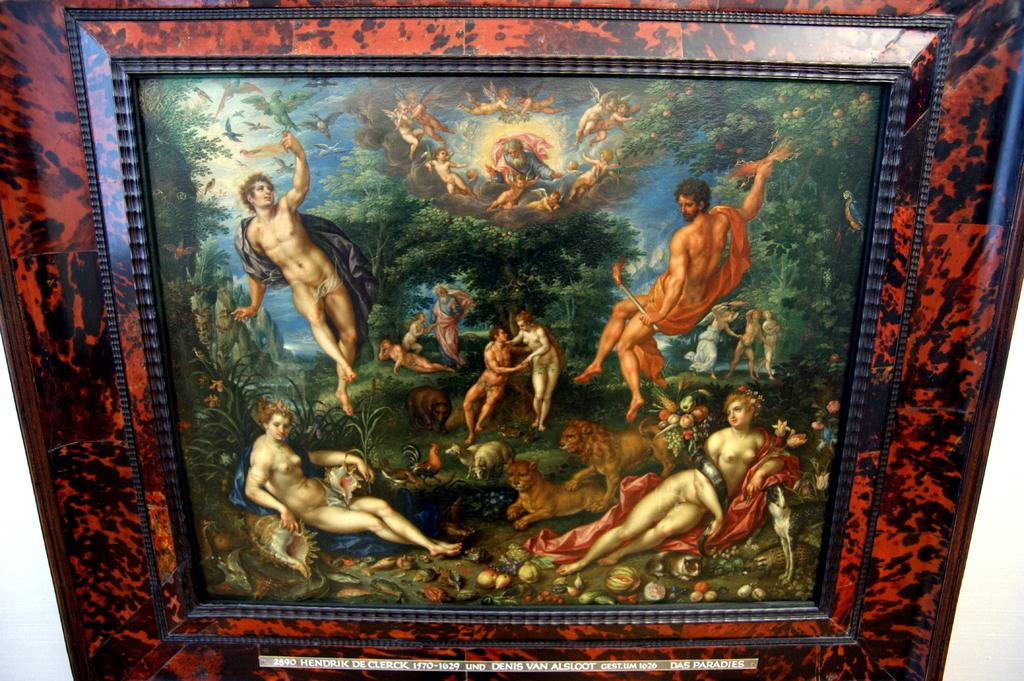<image>
Offer a succinct explanation of the picture presented. A panting has a label below it that reads 2890 Hendrik De Clerck. 